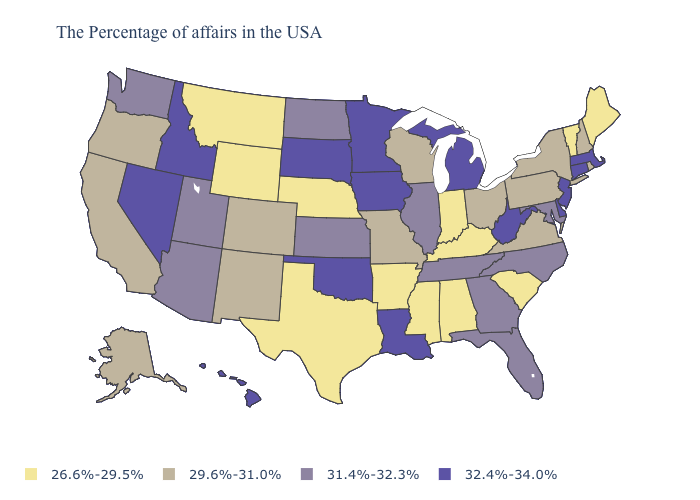Name the states that have a value in the range 29.6%-31.0%?
Write a very short answer. Rhode Island, New Hampshire, New York, Pennsylvania, Virginia, Ohio, Wisconsin, Missouri, Colorado, New Mexico, California, Oregon, Alaska. Which states have the lowest value in the USA?
Quick response, please. Maine, Vermont, South Carolina, Kentucky, Indiana, Alabama, Mississippi, Arkansas, Nebraska, Texas, Wyoming, Montana. What is the value of Nebraska?
Keep it brief. 26.6%-29.5%. Does New Jersey have the highest value in the USA?
Write a very short answer. Yes. Name the states that have a value in the range 31.4%-32.3%?
Concise answer only. Maryland, North Carolina, Florida, Georgia, Tennessee, Illinois, Kansas, North Dakota, Utah, Arizona, Washington. What is the value of Kansas?
Give a very brief answer. 31.4%-32.3%. What is the value of Missouri?
Answer briefly. 29.6%-31.0%. What is the highest value in the West ?
Concise answer only. 32.4%-34.0%. Does Louisiana have the highest value in the USA?
Keep it brief. Yes. Name the states that have a value in the range 31.4%-32.3%?
Answer briefly. Maryland, North Carolina, Florida, Georgia, Tennessee, Illinois, Kansas, North Dakota, Utah, Arizona, Washington. Is the legend a continuous bar?
Short answer required. No. Does the map have missing data?
Give a very brief answer. No. Does the map have missing data?
Be succinct. No. Which states have the lowest value in the Northeast?
Answer briefly. Maine, Vermont. What is the value of Montana?
Be succinct. 26.6%-29.5%. 